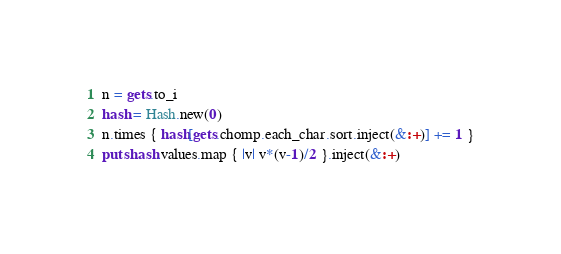<code> <loc_0><loc_0><loc_500><loc_500><_Ruby_>n = gets.to_i
hash = Hash.new(0)
n.times { hash[gets.chomp.each_char.sort.inject(&:+)] += 1 }
puts hash.values.map { |v| v*(v-1)/2 }.inject(&:+)</code> 